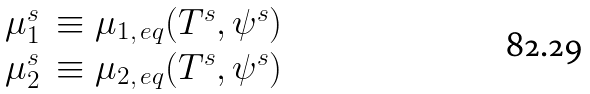<formula> <loc_0><loc_0><loc_500><loc_500>\begin{array} { r l } \mu _ { 1 } ^ { s } & \equiv \mu _ { 1 , \, e q } ( T ^ { s } , \psi ^ { s } ) \\ \mu _ { 2 } ^ { s } & \equiv \mu _ { 2 , \, e q } ( T ^ { s } , \psi ^ { s } ) \\ \end{array}</formula> 